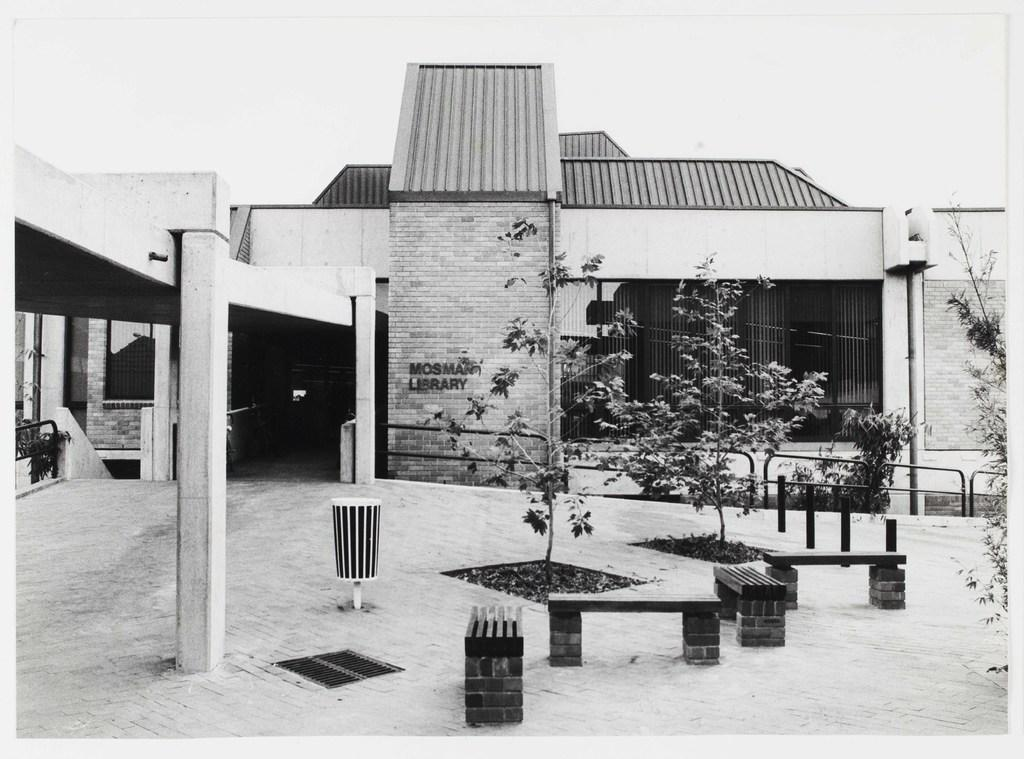What type of structure can be seen in the background of the image? There is a building in the background of the image. What objects are located in the foreground of the image? There are benches and trees in the foreground of the image. What feature separates the different areas in the image? There is a boundary in the image. What is the condition of the sky in the image? The sky is clear in the image. What object is present for waste disposal? A dustbin is present in the image. Is there a mountain visible in the image? No, there is no mountain present in the image. What season is depicted in the image, considering the clear sky? The clear sky does not indicate a specific season; it could be any season. 